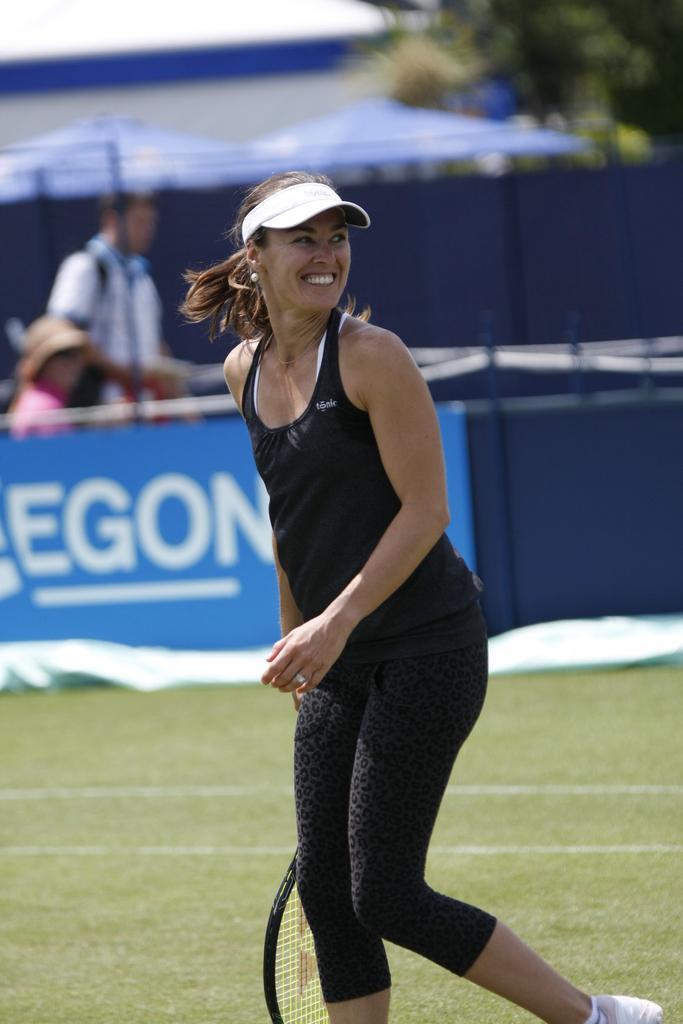Please provide a concise description of this image. In the foreground of the picture there is a woman in black dress holding a racket and there is grass also. In the middle of the picture there are canopies, banner, people and trees. In the background it is blurred. 